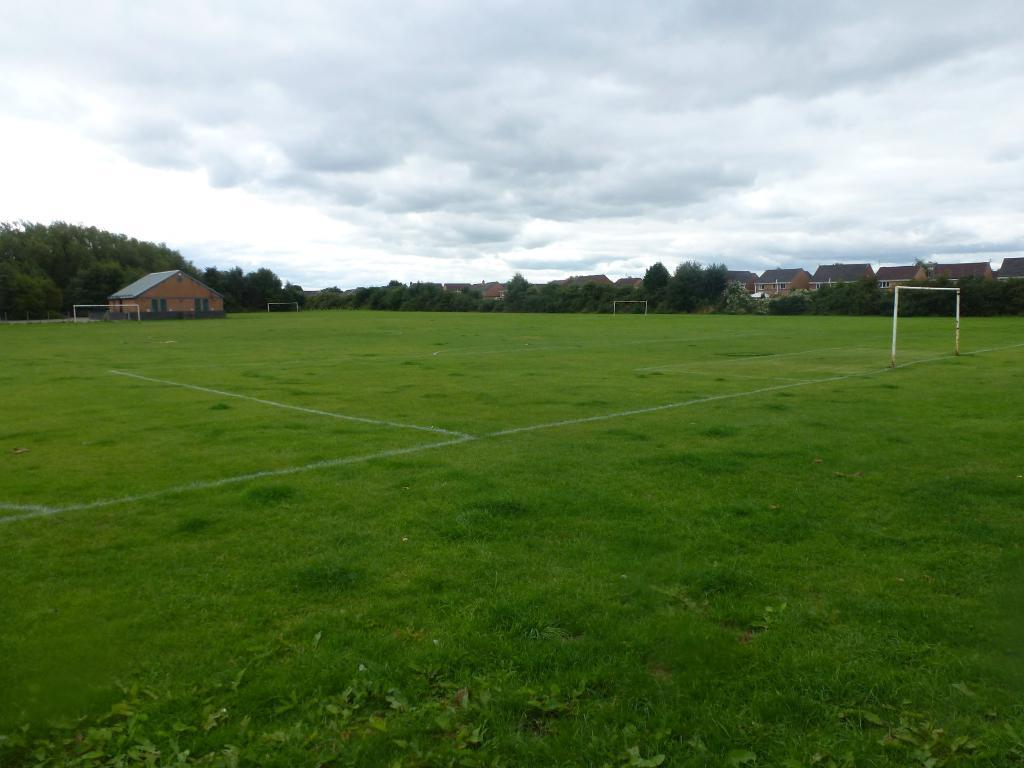What type of structures can be seen in the image? There are houses in the image. What else can be found on the ground in the image? There are poles on the ground in the image. What type of vegetation is present in the image? There are trees, bushes, plants, and grass in the image. What is visible at the top of the image? The sky is visible at the top of the image. How would you describe the sky in the image? The sky appears to be cloudy in the image. How many goats are visible in the image? There are no goats present in the image. What day of the week is it in the image? The image does not provide information about the day of the week. 